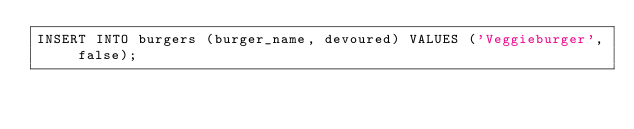<code> <loc_0><loc_0><loc_500><loc_500><_SQL_>INSERT INTO burgers (burger_name, devoured) VALUES ('Veggieburger', false);</code> 